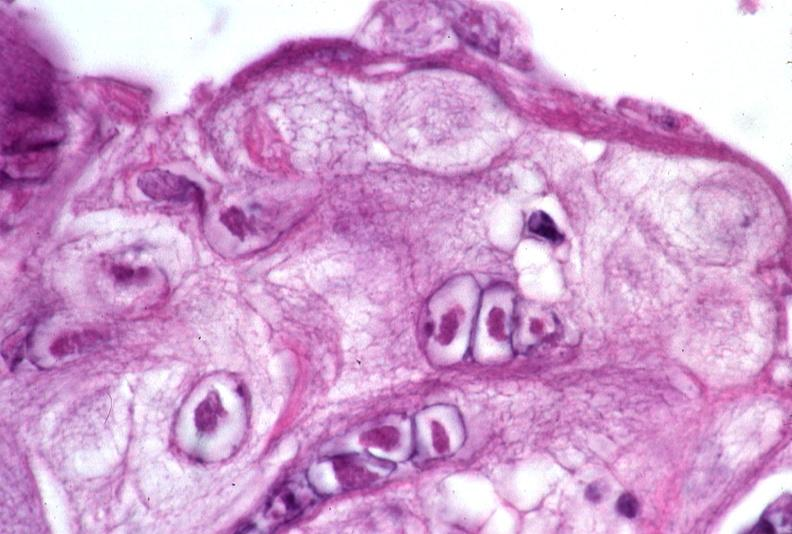where is this?
Answer the question using a single word or phrase. Skin 